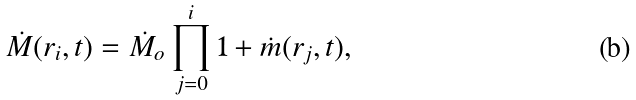Convert formula to latex. <formula><loc_0><loc_0><loc_500><loc_500>\dot { M } ( r _ { i } , t ) = \dot { M } _ { o } \prod ^ { i } _ { j = 0 } 1 + \dot { m } ( r _ { j } , t ) ,</formula> 